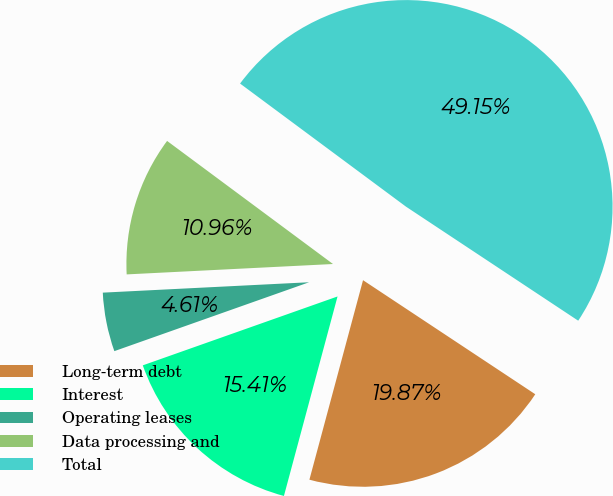Convert chart. <chart><loc_0><loc_0><loc_500><loc_500><pie_chart><fcel>Long-term debt<fcel>Interest<fcel>Operating leases<fcel>Data processing and<fcel>Total<nl><fcel>19.87%<fcel>15.41%<fcel>4.61%<fcel>10.96%<fcel>49.15%<nl></chart> 